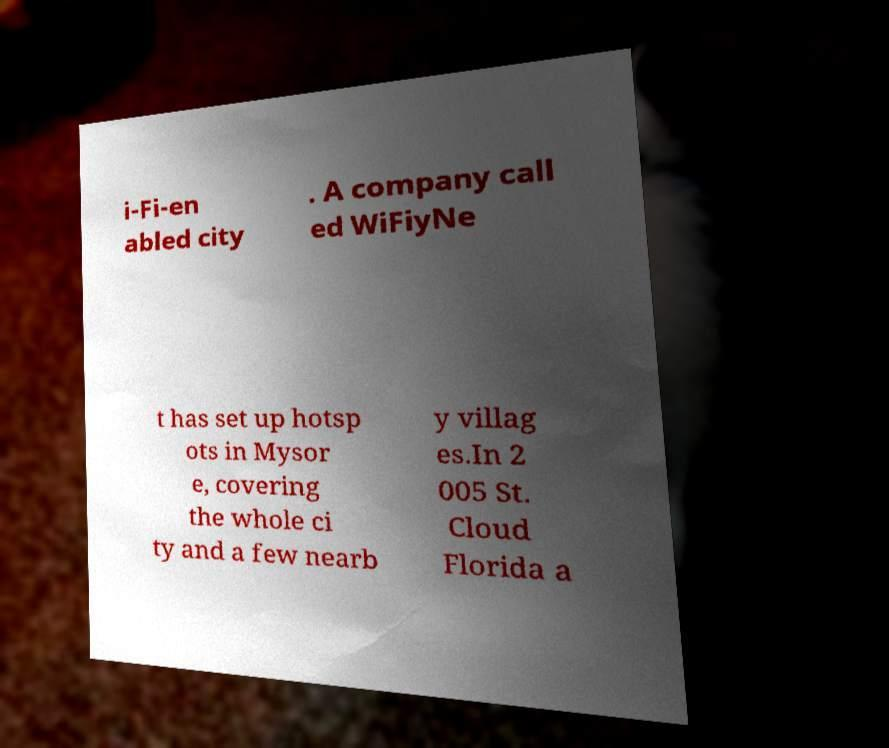Could you extract and type out the text from this image? i-Fi-en abled city . A company call ed WiFiyNe t has set up hotsp ots in Mysor e, covering the whole ci ty and a few nearb y villag es.In 2 005 St. Cloud Florida a 